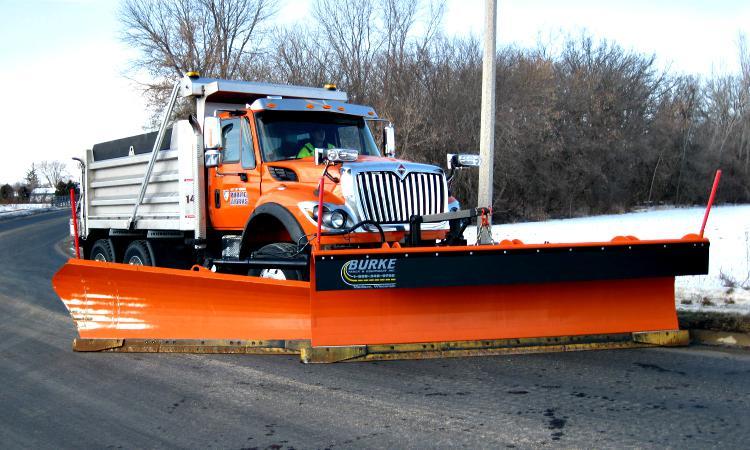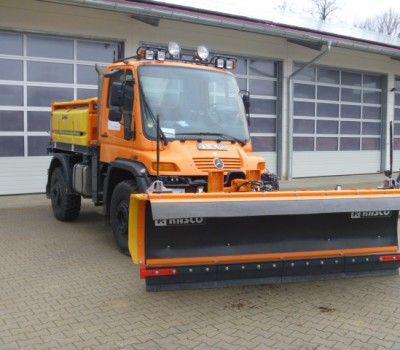The first image is the image on the left, the second image is the image on the right. For the images displayed, is the sentence "The image on the left contains exactly one yellow truck" factually correct? Answer yes or no. No. 